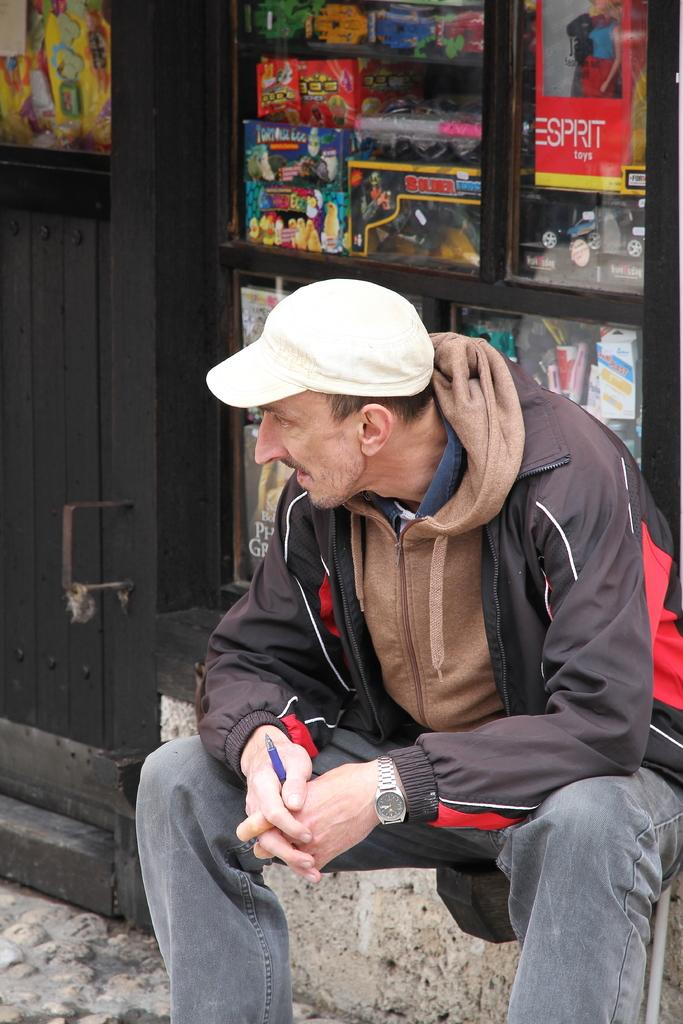What is the man in the image doing? The man is sitting in the image. What is the man wearing? The man is wearing clothes, a wrist watch, and a cap. What is the man holding in his hand? The man is holding a pen in his hand. What can be seen in the background of the image? There is a door visible in the image, and it appears to be of a shop. How many pieces of furniture can be seen in the image? There is no furniture visible in the image; it only shows a man sitting and a door in the background. 